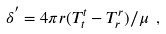<formula> <loc_0><loc_0><loc_500><loc_500>\delta ^ { ^ { \prime } } = 4 \pi r ( T ^ { t } _ { t } - T ^ { r } _ { r } ) / \mu \ ,</formula> 